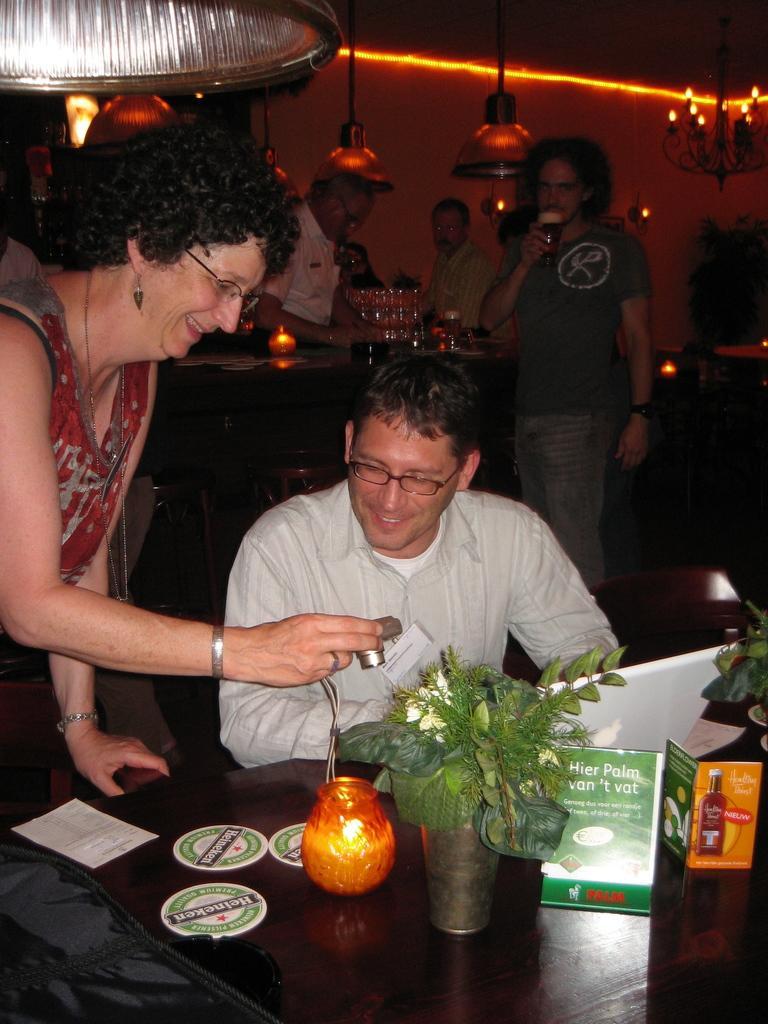Please provide a concise description of this image. In this picture there is a guy who is siting on the table with food items on top of it and a lady is showing a camera to it. In the background we observe many people standing and there are beautiful lights to the roof. 